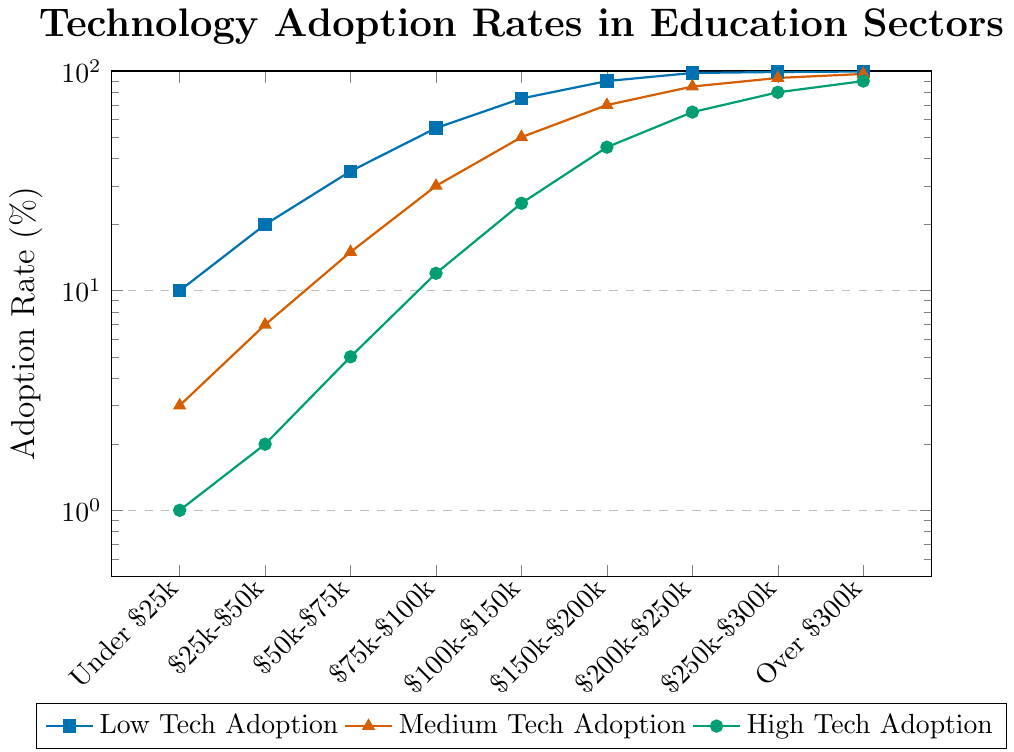What's the highest adoption rate of high technology, and in which income bracket is it? The chart shows that the highest adoption rate of high technology is achieved in the 'Over $300k' income bracket, marked by the highest point on the high technology line (green)
Answer: 90%, Over $300k Compare the adoption rate of medium technology in the $50k-$75k bracket to the $100k-$150k bracket In the $50k-$75k bracket, medium tech adoption is 15%, whereas it is 50% in the $100k-$150k bracket. Comparing these, 50% is higher than 15%
Answer: It is higher in the $100k-$150k bracket What is the percentage point increase in low-tech adoption from the 'Under $25k' bracket to the '$75k-$100k' bracket? Low-tech adoption in the 'Under $25k' bracket is 10%, and in the '$75k-$100k' bracket, it is 55%. The increase is 55% - 10% = 45%
Answer: 45% What is the difference between the high-tech adoption rate in the $150k-$200k bracket and the medium-tech adoption rate in the same bracket? High-tech adoption in the $150k-$200k bracket is 45%, and medium-tech adoption is 70%. The difference is 70% - 45% = 25%
Answer: 25% Based on the chart, which technology adoption category shows a constant increase across income brackets without any decrease or plateau? By looking at the trends, the low-tech adoption line consistently rises without any drops or plateaus
Answer: Low-tech adoption By how much does the adoption rate of medium technology increase from the '$50k-$75k' bracket to the '$200k-$250k' bracket? Medium-tech adoption in the '$50k-$75k' bracket is 15%, and in the '$200k-$250k' bracket, it is 85%. The increase is 85% - 15% = 70%
Answer: 70% What can you infer about the trend of high-tech adoption as income increases? Observing the green line, high-tech adoption increases consistently as income brackets increase.
Answer: It increases uniformly Which income bracket exhibits the smallest gap between medium and high-tech adoption rates? The smallest gap appears in the 'Over $300k' bracket, where medium is 97% and high is 90%, giving a difference of 97% - 90% = 7%
Answer: Over $300k What is the approximate ratio of low-tech to high-tech adoption in the '$25k-$50k' bracket? Low-tech adoption in the '$25k-$50k' bracket is 20%, and high-tech adoption is 2%. The ratio is 20% / 2% = 10
Answer: 10:1 